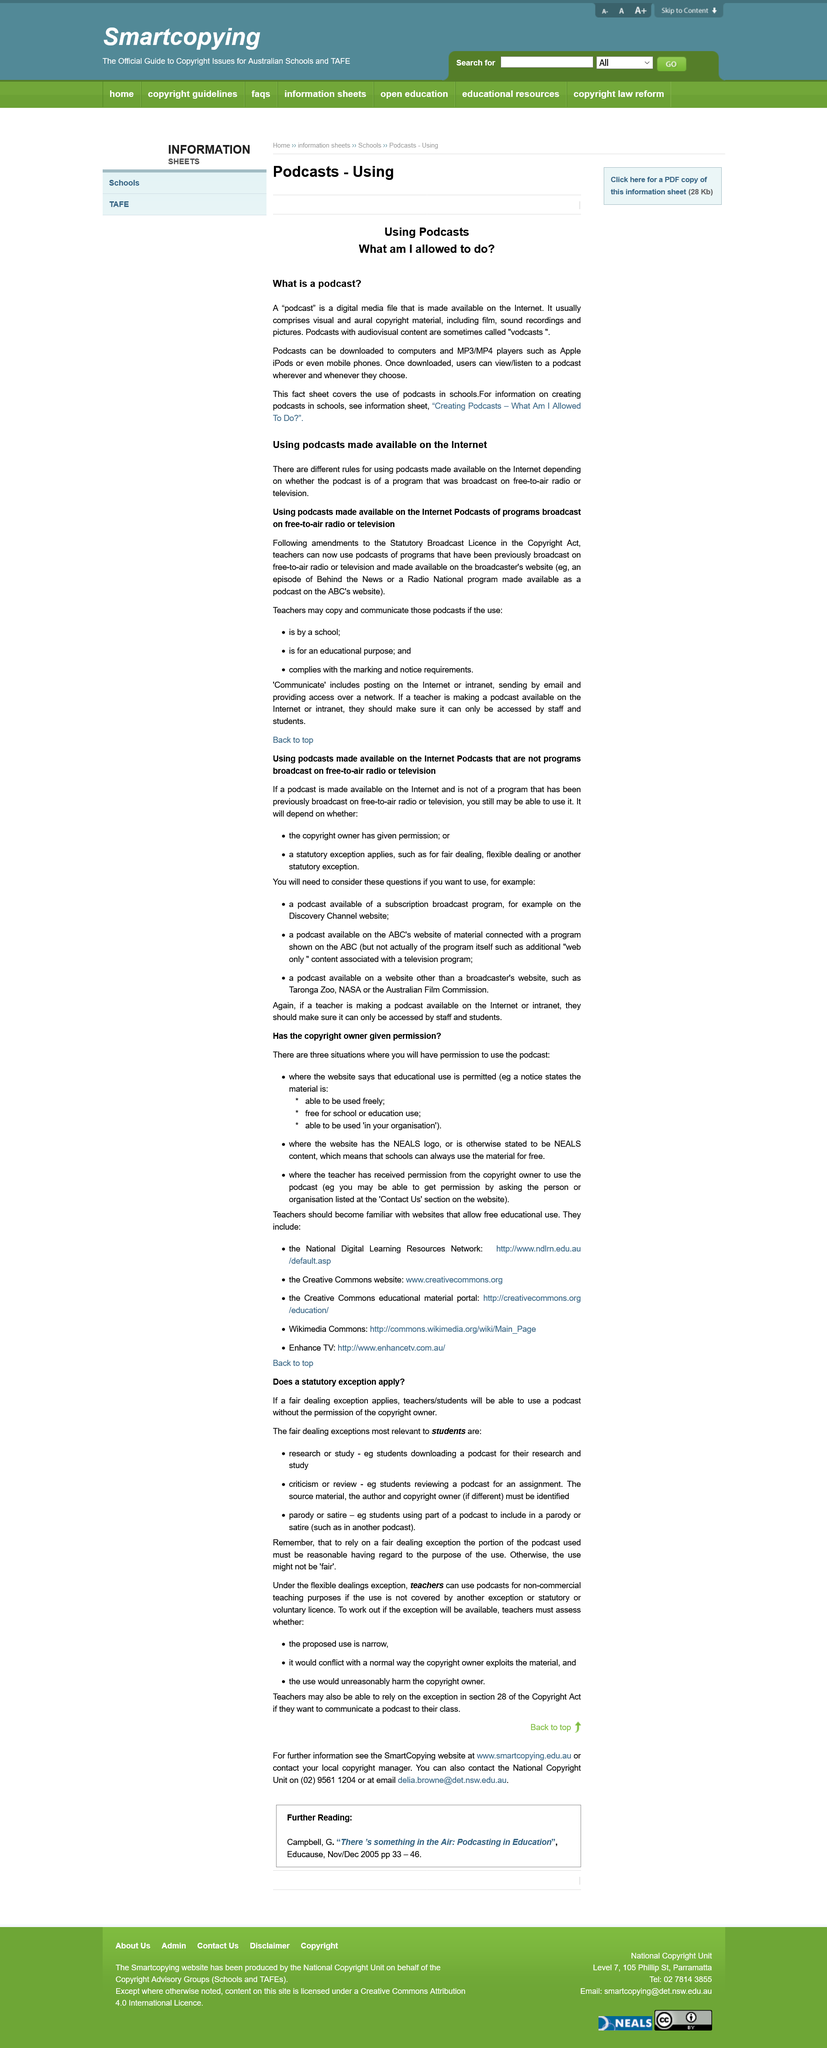Identify some key points in this picture. Podcasts with audiovisual content are sometimes referred to as vodcasts. If I want to use a podcast available on a subscription broadcast program, such as one on the Discovery Channel website, I should consider several questions to ensure its suitability for my needs. The article discusses the Statutory Broadcast License, which is governed by the provisions of the Copyright Act. It is permissible to use the podcast in three situations. Teachers may use a podcast without seeking permission from the copyright owner if a fair dealing exception applies. 